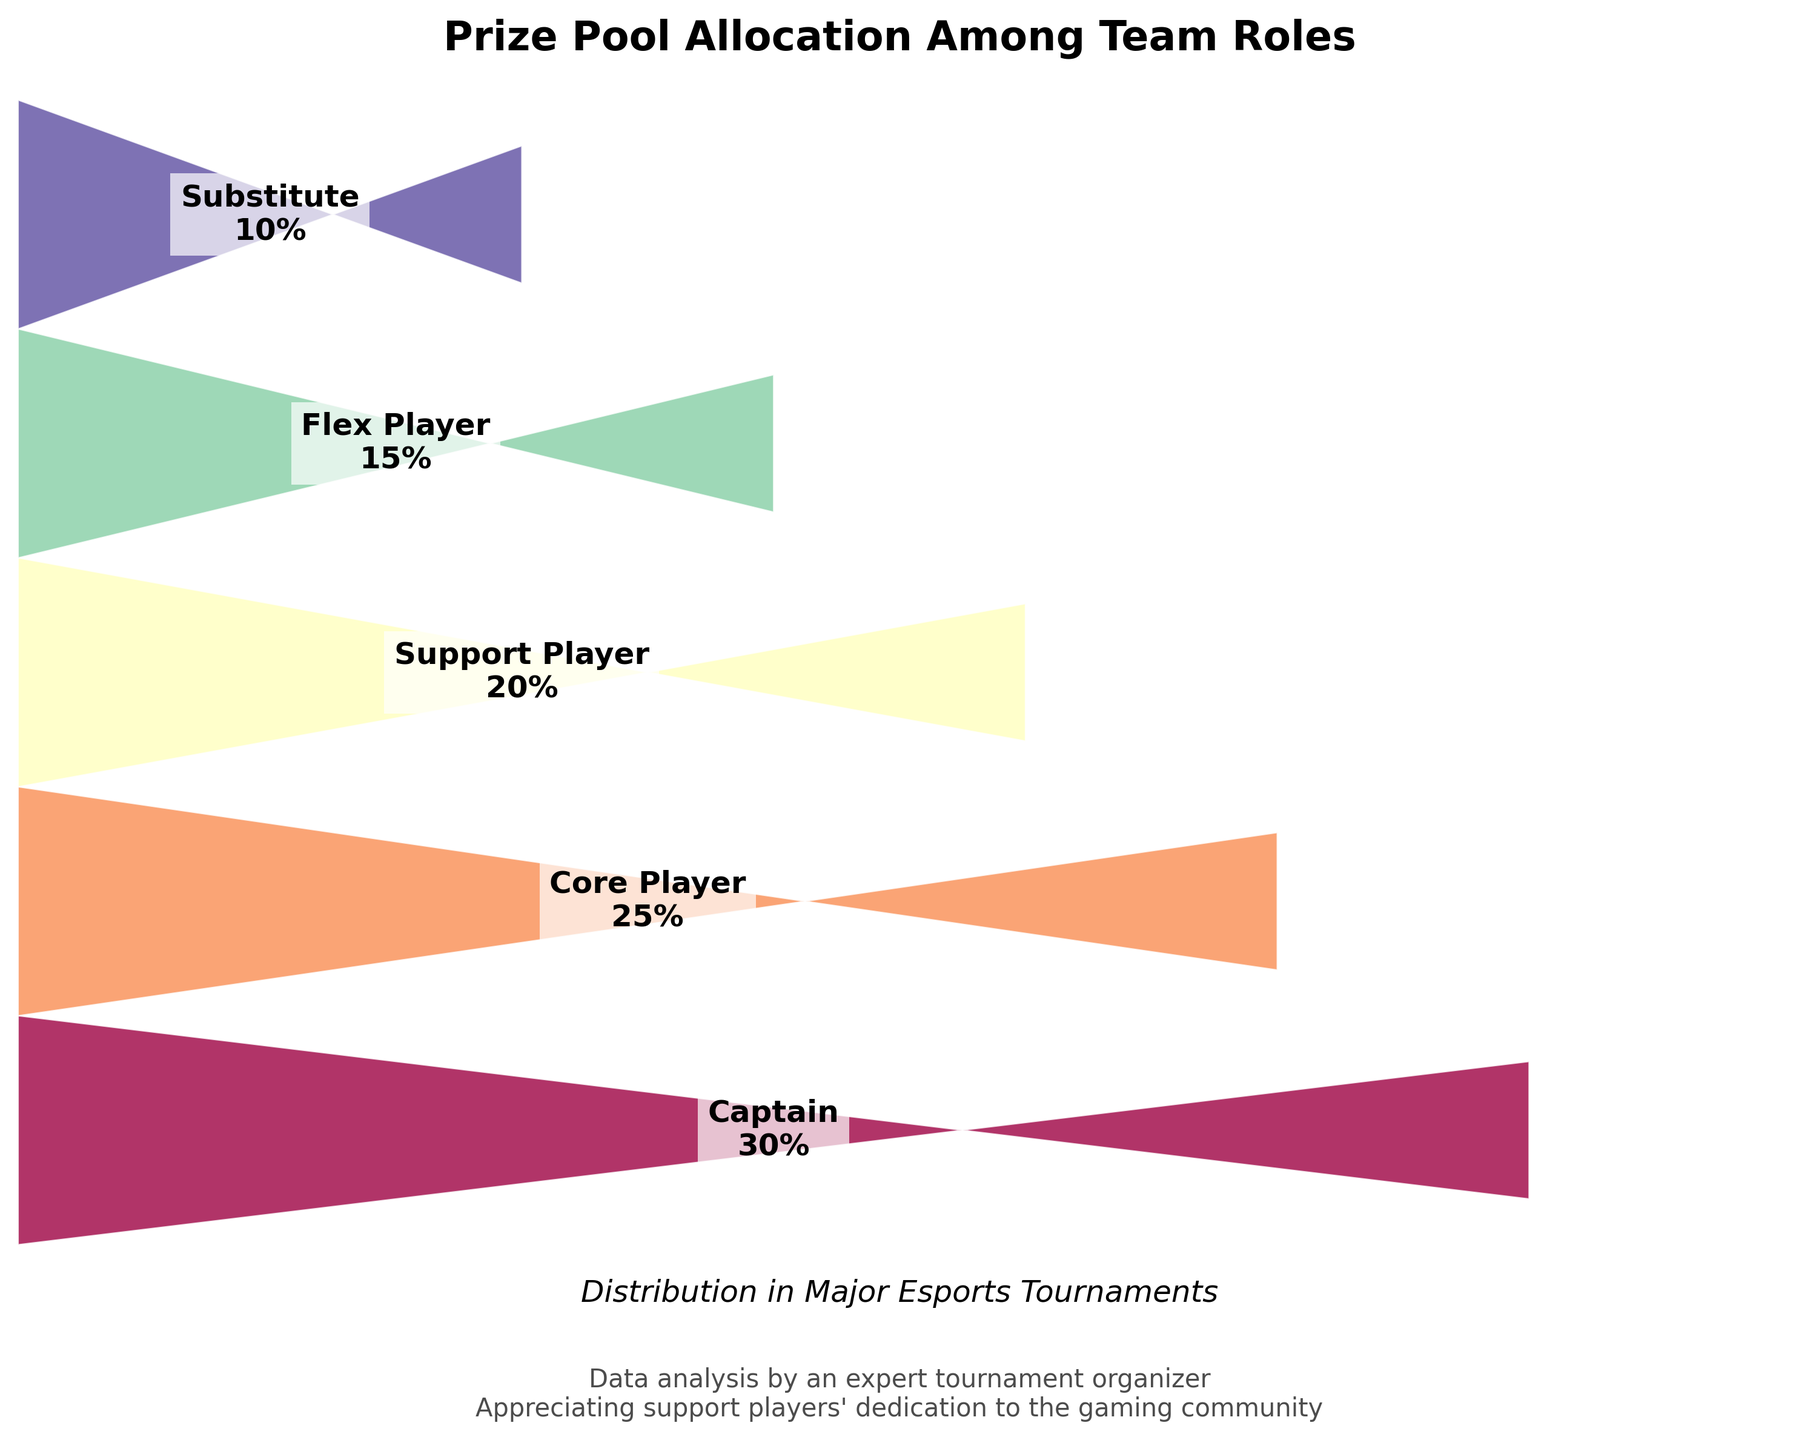What's the title of the figure? The title is located at the top of the figure and clearly states what the figure is about.
Answer: Prize Pool Allocation Among Team Roles Which role receives the largest percentage of the prize pool? By looking at the figure, the role at the top with the highest percentage label can be identified.
Answer: Captain What's the total percentage allocation among Support Player, Flex Player, and Substitute? Identify the percentages of these roles (20% for Support Player, 15% for Flex Player, 10% for Substitute) and sum them up: 20 + 15 + 10.
Answer: 45% How much more percentage does the Core Player receive compared to the Substitute? Identify the percentages for Core Player (25%) and Substitute (10%), then find their difference: 25 - 10.
Answer: 15% Which roles have a larger percentage than the Support Player? Compare the Support Player's percentage (20%) with others. The ones greater are Captain (30%) and Core Player (25%).
Answer: Captain, Core Player Where do the text labels for the roles appear on the trapezoids? By visually inspecting the figure, observe where the text labels are placed on each trapezoid.
Answer: Centered along the middle line of each trapezoid What is the subtitle of the figure? The subtitle is located beneath the main title and provides additional context.
Answer: Distribution in Major Esports Tournaments Which role gets half the percentage of the Captain? Identify the percentage of the Captain (30%) and find which role has about half of that. The Flex Player with 15% matches.
Answer: Flex Player What’s the average percentage allocation among all roles? Sum all percentages (30 + 25 + 20 + 15 + 10) to get 100, then divide by the number of roles (5): 100 / 5.
Answer: 20% How are the colors of the trapezoids distributed for the roles? By looking at the figure, notice the color gradient from one role to the next, ensuring no specific colors need to be named.
Answer: Gradient from one color to another across roles 